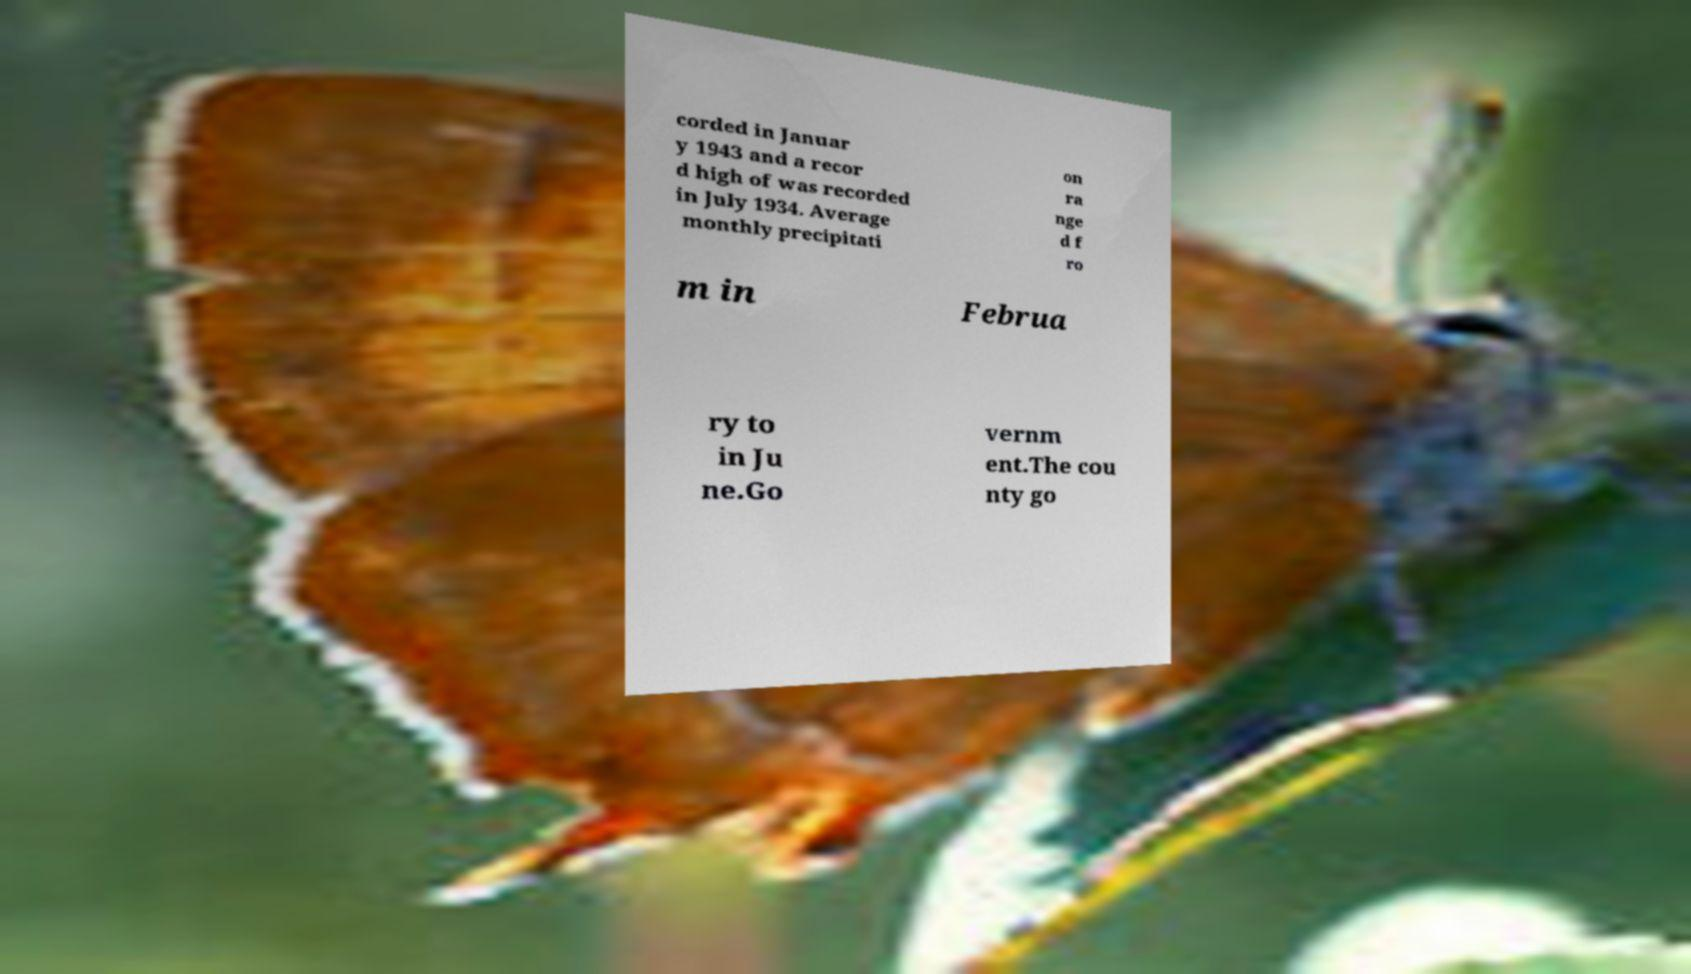Please read and relay the text visible in this image. What does it say? corded in Januar y 1943 and a recor d high of was recorded in July 1934. Average monthly precipitati on ra nge d f ro m in Februa ry to in Ju ne.Go vernm ent.The cou nty go 